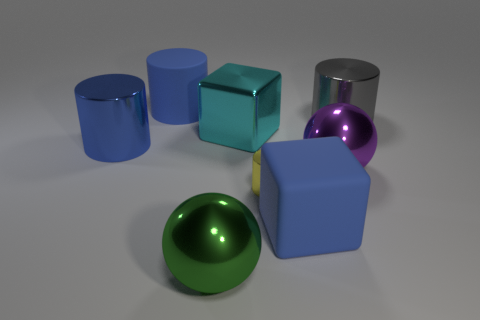Add 1 big blue metallic cubes. How many objects exist? 9 Subtract all spheres. How many objects are left? 6 Add 1 big metallic blocks. How many big metallic blocks exist? 2 Subtract 0 red cylinders. How many objects are left? 8 Subtract all big green shiny objects. Subtract all yellow metallic things. How many objects are left? 6 Add 2 blue rubber things. How many blue rubber things are left? 4 